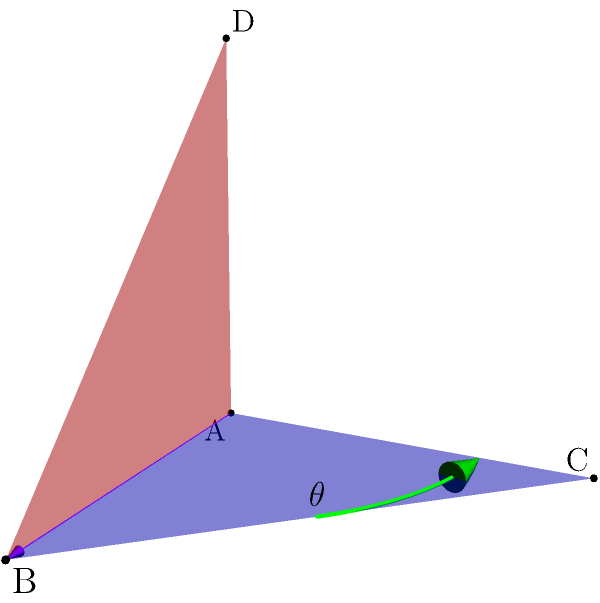In the given 3D space, two planes intersect along line AB. Plane ABC is represented in blue, and plane ABD is shown in red. If the normal vectors to these planes are $\vec{n_1} = (0, 0, 1)$ and $\vec{n_2} = (0, -1, 0)$ respectively, determine the angle $\theta$ between these two planes. To find the angle between two intersecting planes, we can use the dot product of their normal vectors. The steps are as follows:

1) We are given the normal vectors:
   $\vec{n_1} = (0, 0, 1)$ and $\vec{n_2} = (0, -1, 0)$

2) The formula for the angle between two planes is:
   $$\cos \theta = \frac{|\vec{n_1} \cdot \vec{n_2}|}{\|\vec{n_1}\| \|\vec{n_2}\|}$$

3) Calculate the dot product $\vec{n_1} \cdot \vec{n_2}$:
   $\vec{n_1} \cdot \vec{n_2} = (0)(0) + (0)(-1) + (1)(0) = 0$

4) Calculate the magnitudes of the normal vectors:
   $\|\vec{n_1}\| = \sqrt{0^2 + 0^2 + 1^2} = 1$
   $\|\vec{n_2}\| = \sqrt{0^2 + (-1)^2 + 0^2} = 1$

5) Substitute into the formula:
   $$\cos \theta = \frac{|0|}{(1)(1)} = 0$$

6) Solve for $\theta$:
   $$\theta = \arccos(0) = \frac{\pi}{2}$$

7) Convert to degrees:
   $$\theta = \frac{\pi}{2} \cdot \frac{180°}{\pi} = 90°$$

Therefore, the angle between the two planes is 90°.
Answer: 90° 